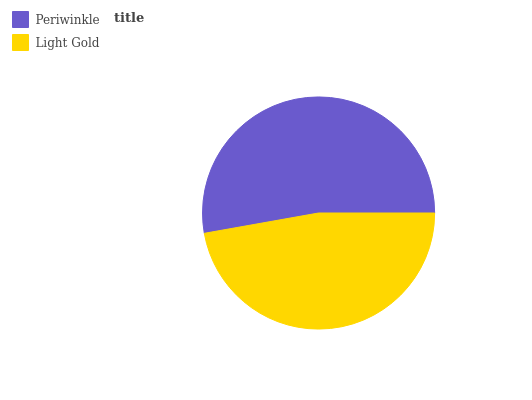Is Light Gold the minimum?
Answer yes or no. Yes. Is Periwinkle the maximum?
Answer yes or no. Yes. Is Light Gold the maximum?
Answer yes or no. No. Is Periwinkle greater than Light Gold?
Answer yes or no. Yes. Is Light Gold less than Periwinkle?
Answer yes or no. Yes. Is Light Gold greater than Periwinkle?
Answer yes or no. No. Is Periwinkle less than Light Gold?
Answer yes or no. No. Is Periwinkle the high median?
Answer yes or no. Yes. Is Light Gold the low median?
Answer yes or no. Yes. Is Light Gold the high median?
Answer yes or no. No. Is Periwinkle the low median?
Answer yes or no. No. 